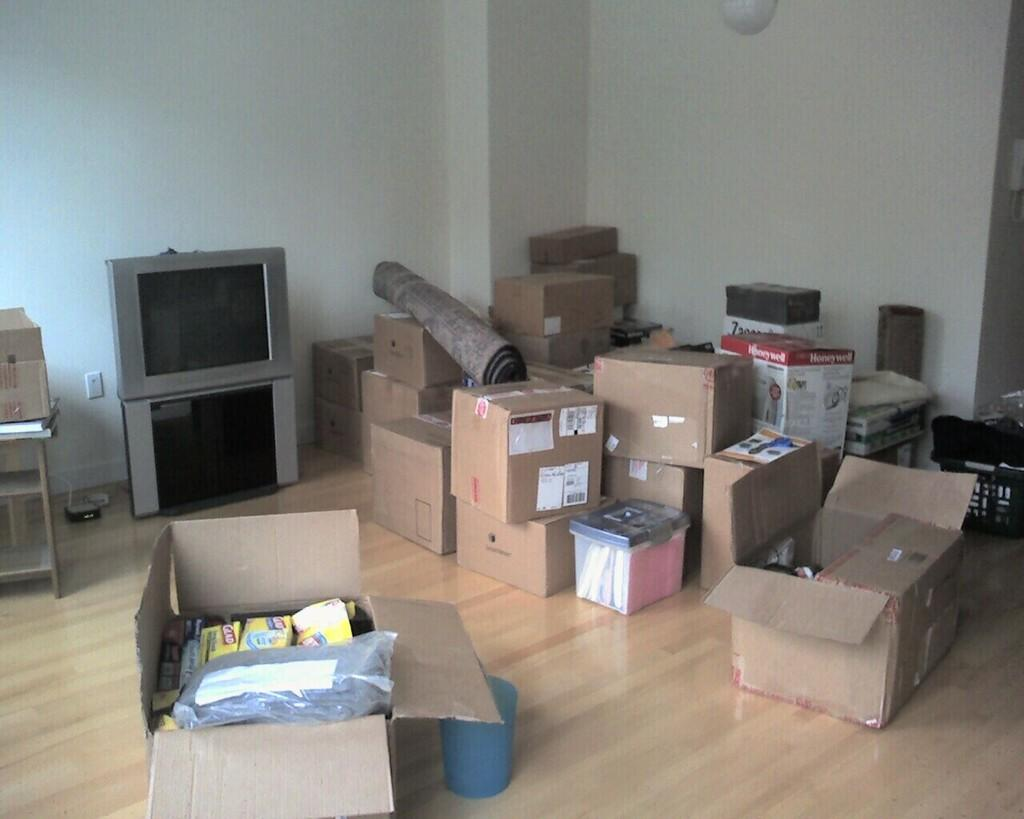What objects are located in the middle of the image? There are boxes, tables, and a screen in the middle of the image. What type of surface can be used for placing items in the image? The tables in the middle of the image can be used for placing items. What is the purpose of the screen in the image? The purpose of the screen in the image is not specified, but it could be used for displaying information or images. What architectural feature is visible in the image? There is a wall visible in the image. How does the growth of the plants affect the sorting of the boxes in the image? There are no plants visible in the image, so the growth of plants cannot affect the sorting of the boxes. 